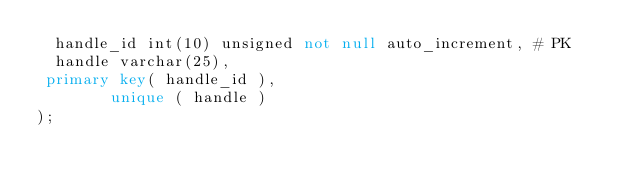Convert code to text. <code><loc_0><loc_0><loc_500><loc_500><_SQL_>  handle_id int(10) unsigned not null auto_increment, # PK 
  handle varchar(25),
 primary key( handle_id ),
        unique ( handle )
);
 
</code> 